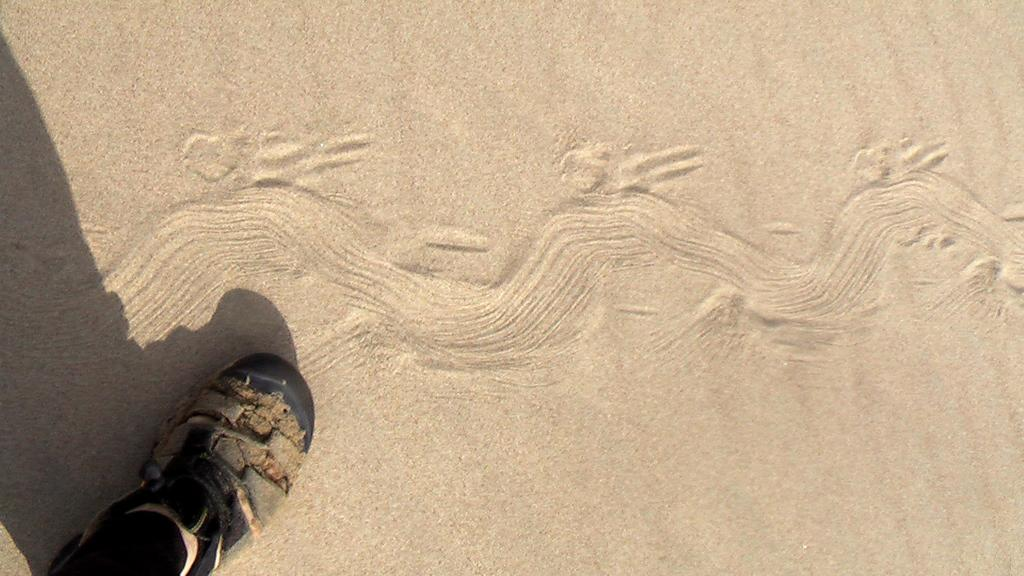What object can be seen on the floor at the bottom of the image? There is a person's shoe visible on the floor at the bottom of the image. How does the guide manage the crowd after the event in the image? There is no guide, crowd, or event present in the image; it only shows a person's shoe on the floor. 